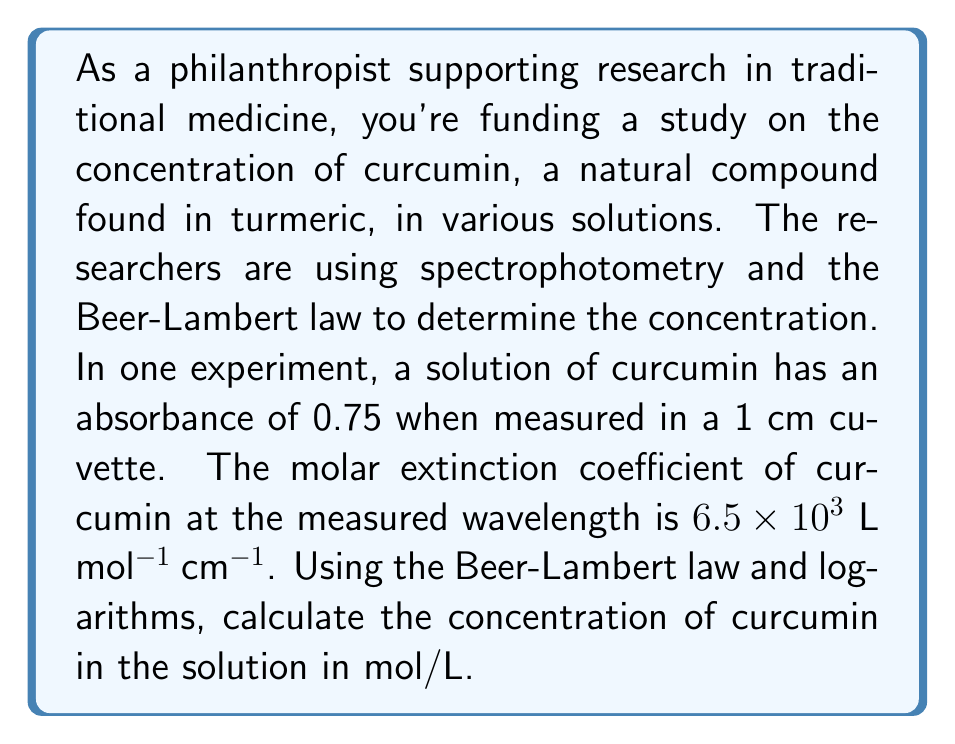Can you solve this math problem? To solve this problem, we'll use the Beer-Lambert law and logarithms. Let's break it down step-by-step:

1) The Beer-Lambert law is given by:

   $$A = \varepsilon bc$$

   Where:
   $A$ = absorbance
   $\varepsilon$ = molar extinction coefficient (L mol$^{-1}$ cm$^{-1}$)
   $b$ = path length (cm)
   $c$ = concentration (mol/L)

2) We're given:
   $A = 0.75$
   $\varepsilon = 6.5 \times 10^3$ L mol$^{-1}$ cm$^{-1}$
   $b = 1$ cm

3) Substituting these values into the Beer-Lambert equation:

   $$0.75 = (6.5 \times 10^3)(1)(c)$$

4) To solve for $c$, we divide both sides by $(6.5 \times 10^3)$:

   $$\frac{0.75}{6.5 \times 10^3} = c$$

5) Now we can calculate $c$:

   $$c = \frac{0.75}{6500} = 1.1538 \times 10^{-4}$$ mol/L

6) To express this using logarithms, we can write:

   $$c = 10^{\log(1.1538 \times 10^{-4})}$$

7) Calculating the logarithm:

   $$\log(1.1538 \times 10^{-4}) = -3.9379$$

8) Therefore, we can express the concentration as:

   $$c = 10^{-3.9379}$$ mol/L
Answer: The concentration of curcumin in the solution is $1.1538 \times 10^{-4}$ mol/L, or equivalently, $10^{-3.9379}$ mol/L. 